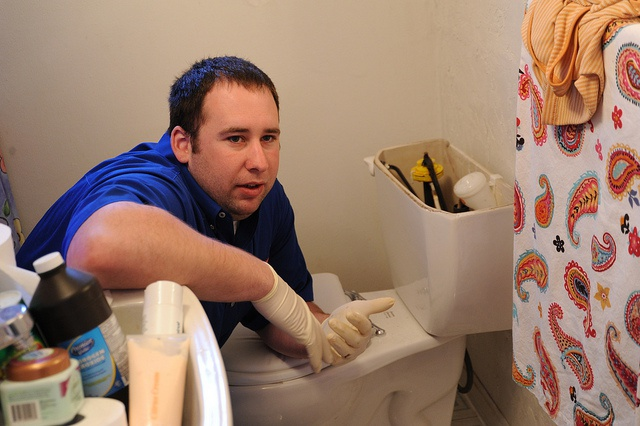Describe the objects in this image and their specific colors. I can see people in darkgray, black, brown, salmon, and navy tones, toilet in darkgray, tan, and gray tones, and bottle in darkgray, black, gray, and tan tones in this image. 